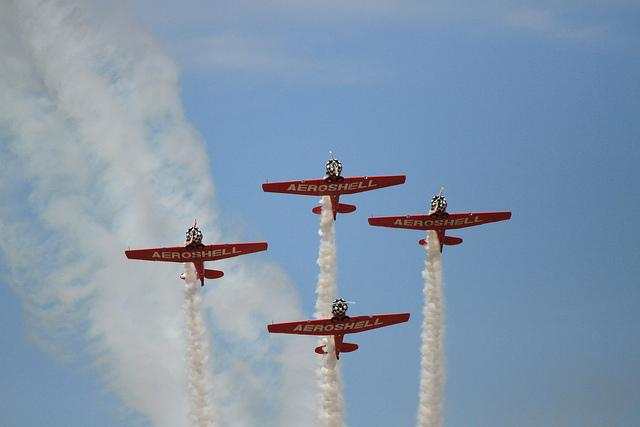What are these planes emitting?

Choices:
A) balloons
B) foam
C) pesticides
D) contrails contrails 